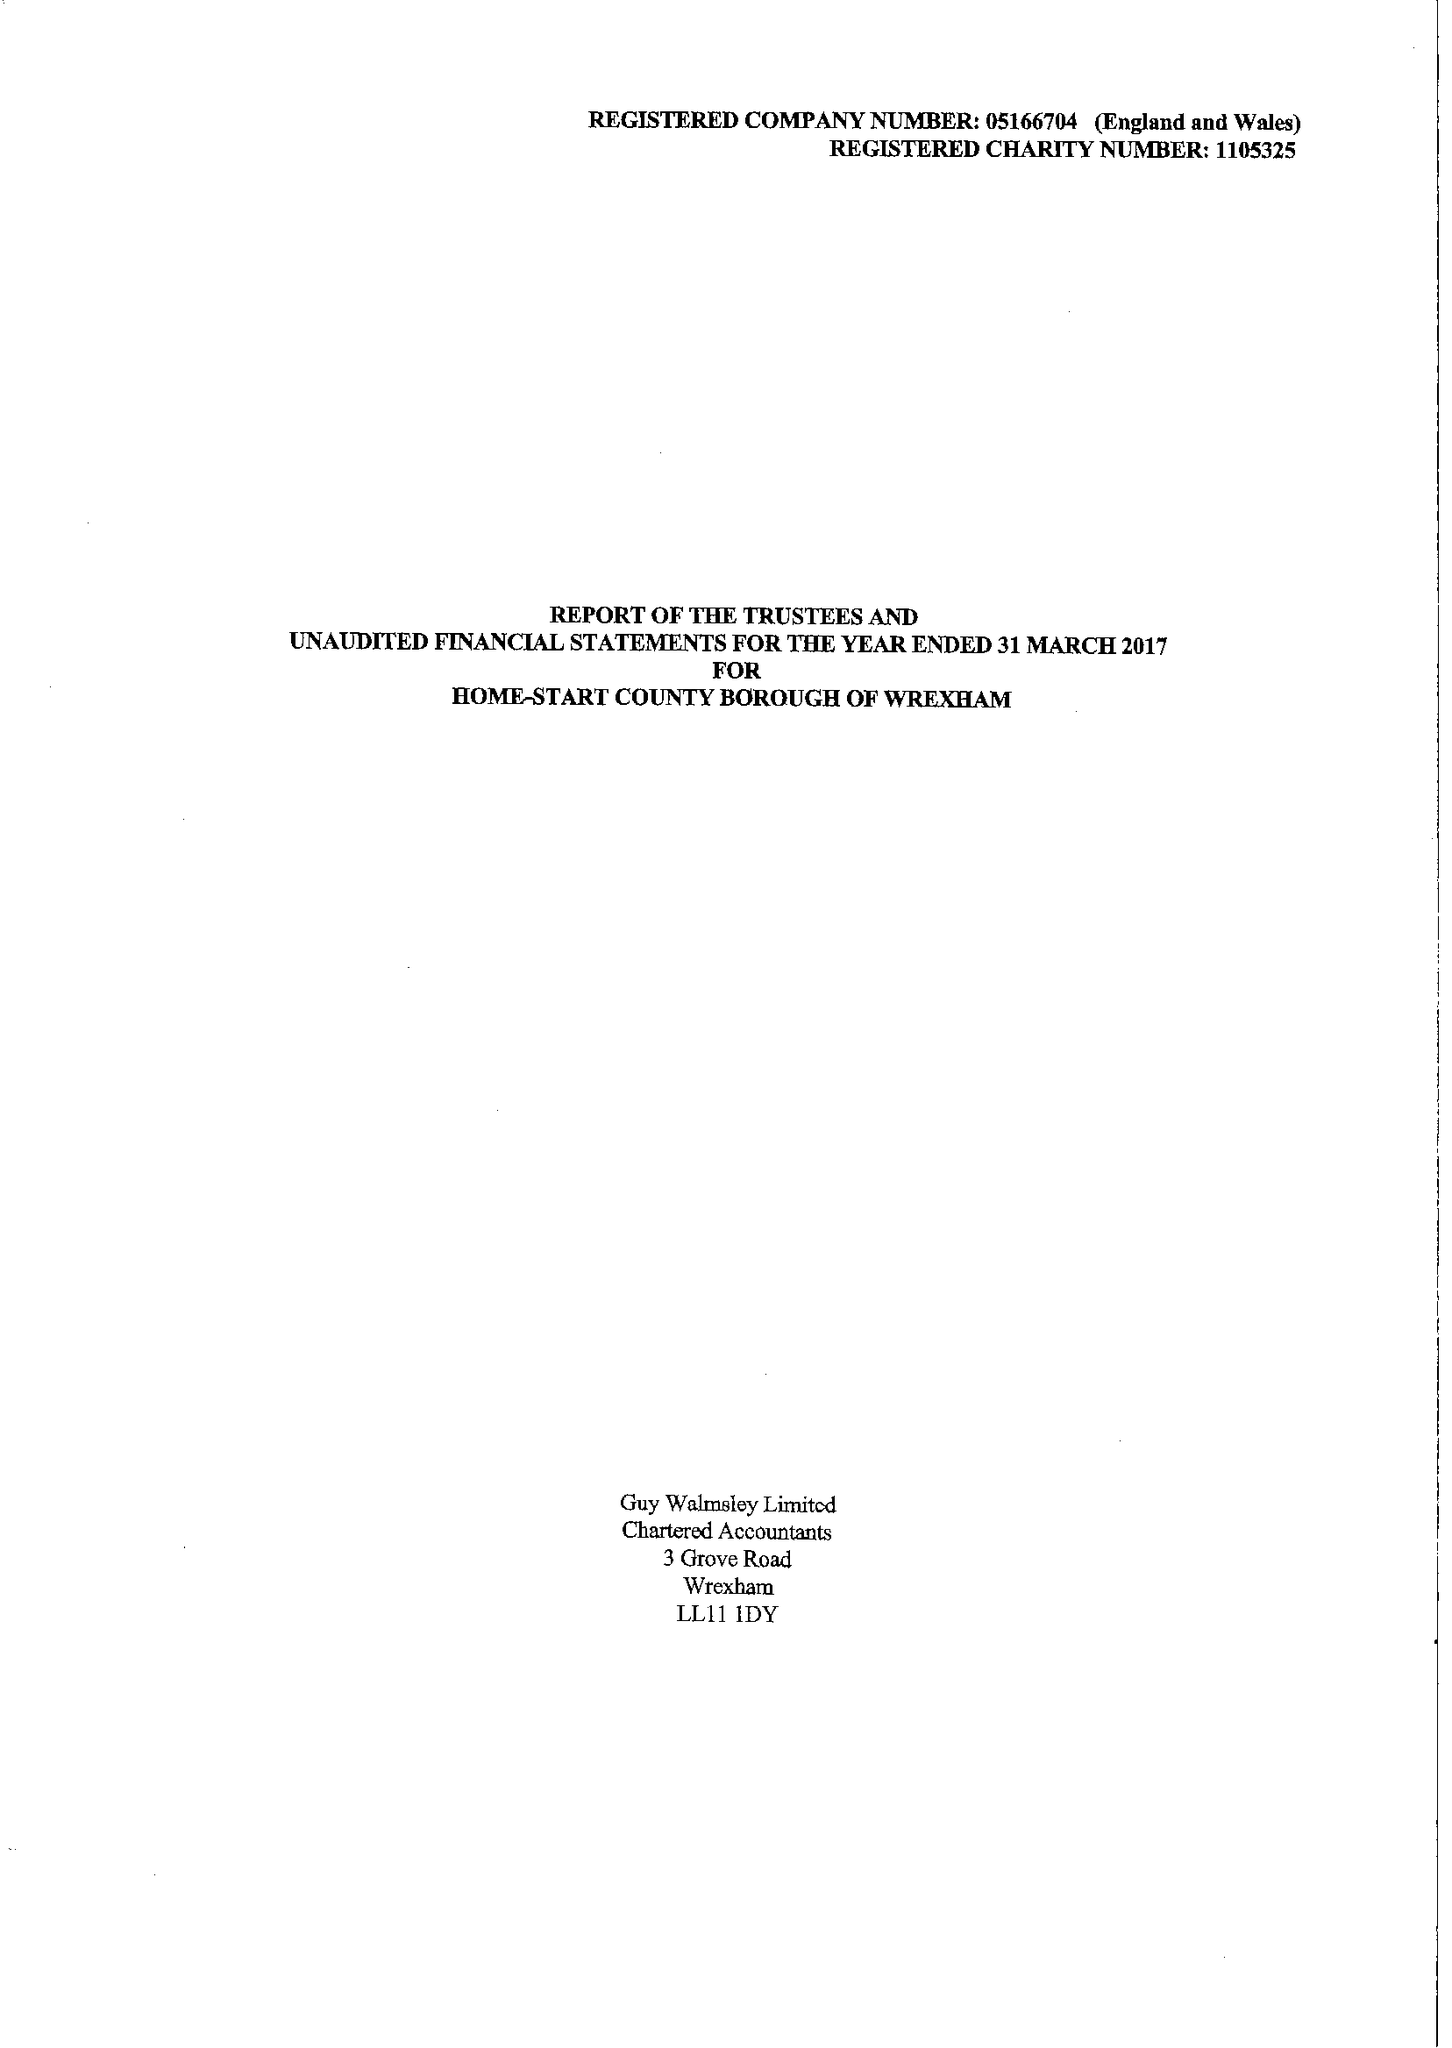What is the value for the spending_annually_in_british_pounds?
Answer the question using a single word or phrase. 135315.00 